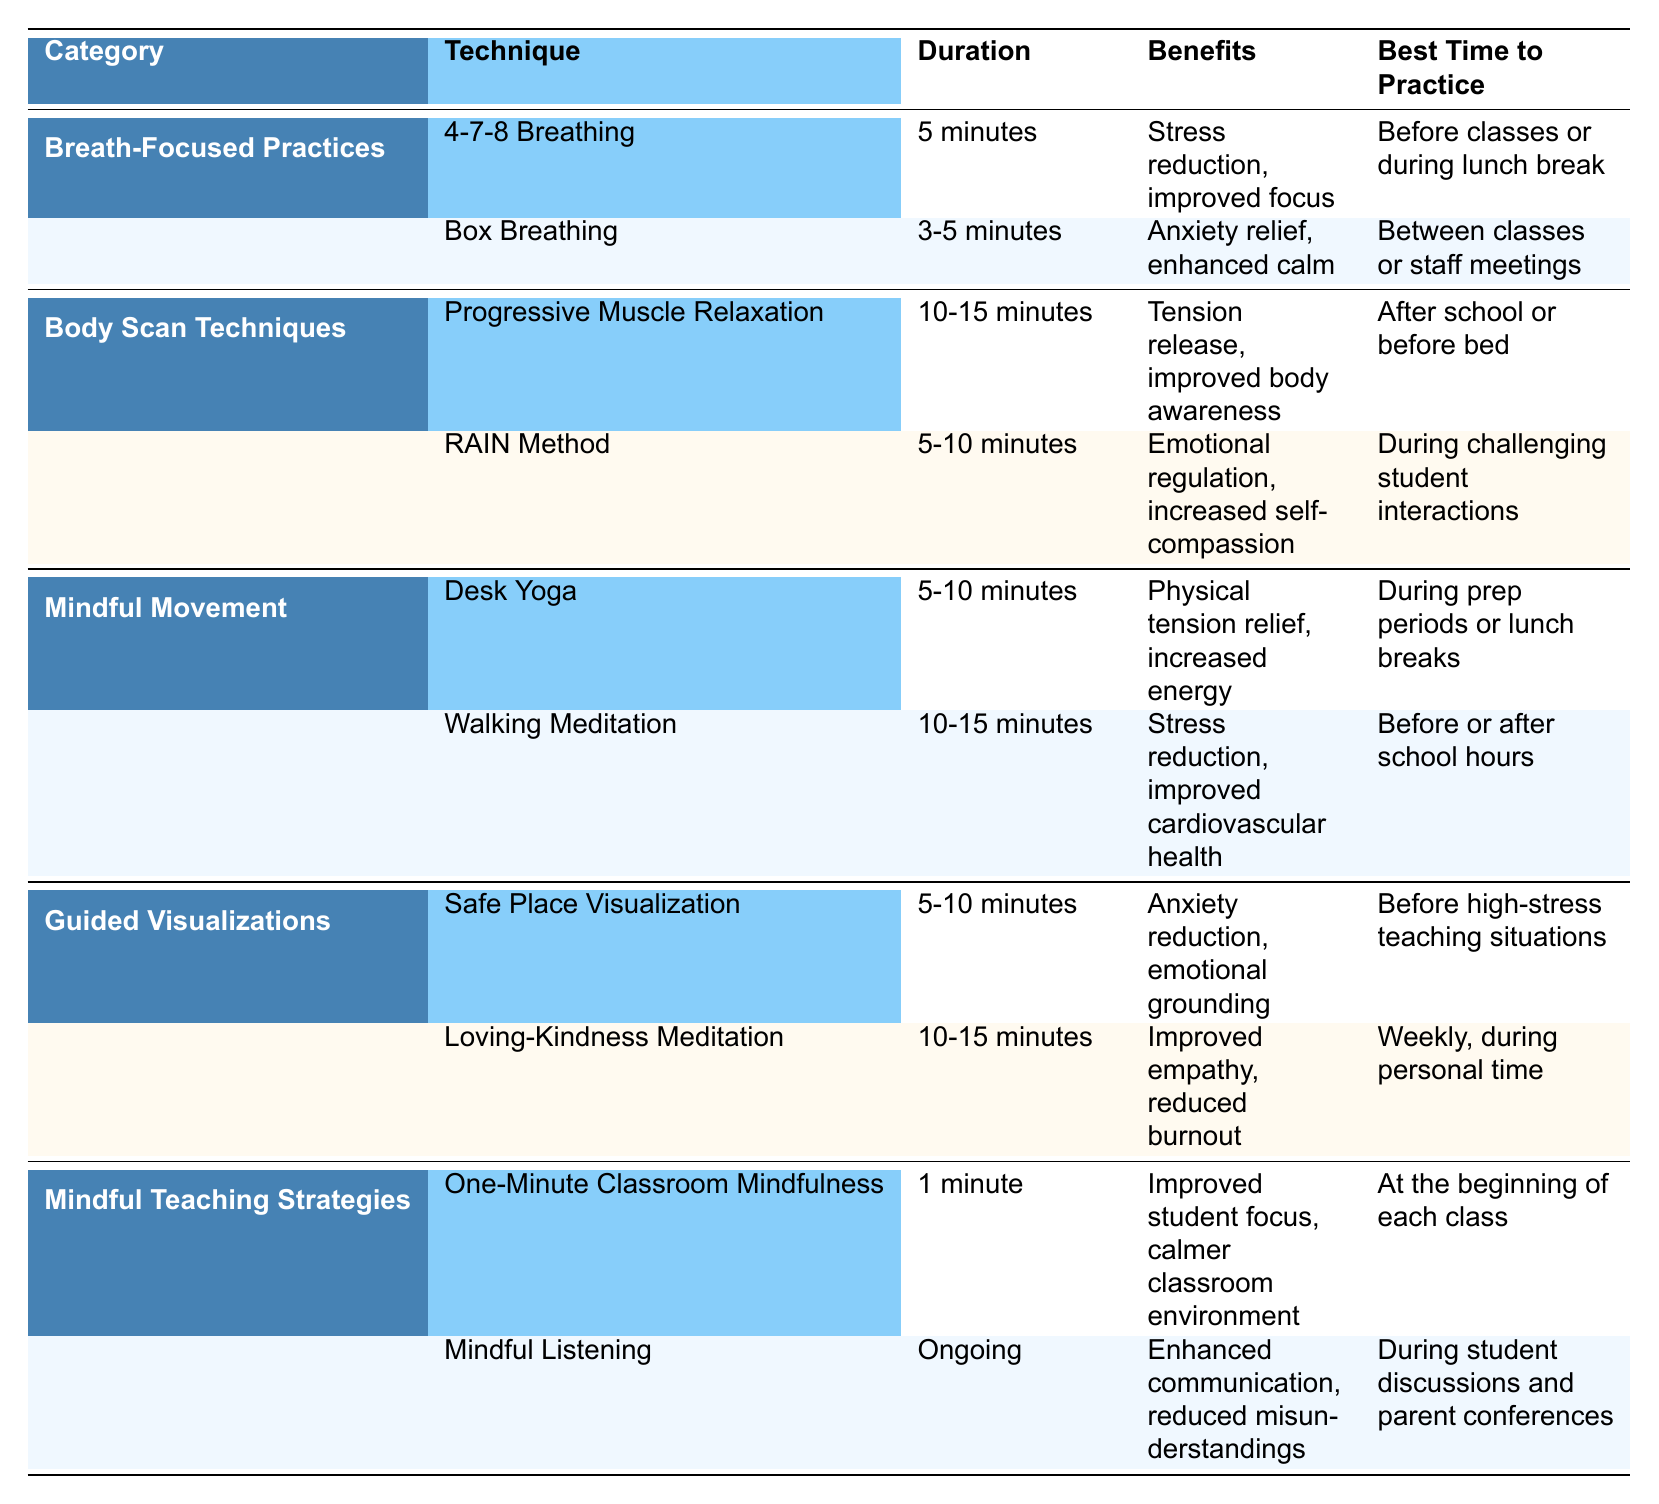What is the duration of the Box Breathing technique? The Box Breathing technique has a specified duration in the table under the "Duration" column, which indicates it lasts for 3-5 minutes.
Answer: 3-5 minutes Which category includes Progressive Muscle Relaxation? By checking the first column for the category names, Progressive Muscle Relaxation is listed under the "Body Scan Techniques" category.
Answer: Body Scan Techniques What benefits are associated with Walking Meditation? The table shows the benefits of Walking Meditation under the corresponding row, which includes stress reduction and improved cardiovascular health.
Answer: Stress reduction, improved cardiovascular health Which technique has the shortest duration and what is it? By looking through the durations listed, the shortest is "One-Minute Classroom Mindfulness," which lasts for just 1 minute.
Answer: One-Minute Classroom Mindfulness Is Loving-Kindness Meditation meant to be practiced weekly? The table states the best time to practice Loving-Kindness Meditation is weekly during personal time, confirming that it is indeed meant for weekly practice.
Answer: Yes How many techniques are there in the Mindful Movement category? The Mindful Movement category contains two techniques, Desk Yoga and Walking Meditation, as seen in the rows under this category.
Answer: 2 Which technique is recommended before high-stress teaching situations? The table indicates that the "Safe Place Visualization" technique is recommended before high-stress teaching situations.
Answer: Safe Place Visualization What is the average duration of Body Scan Techniques? To find the average, add the durations of Progressive Muscle Relaxation (10-15 minutes) and RAIN Method (5-10 minutes). Taking the median of these ranges results in an average duration of 7.5 to 12.5 minutes.
Answer: 7.5 to 12.5 minutes What is the benefit of practicing One-Minute Classroom Mindfulness? The table specifies that the benefits of One-Minute Classroom Mindfulness are improved student focus and a calmer classroom environment.
Answer: Improved student focus, calmer classroom environment Which two techniques have anxiety relief benefits? By reviewing the benefits in the table, it can be noted that the "Box Breathing" and "Safe Place Visualization" techniques both offer anxiety relief.
Answer: Box Breathing, Safe Place Visualization 